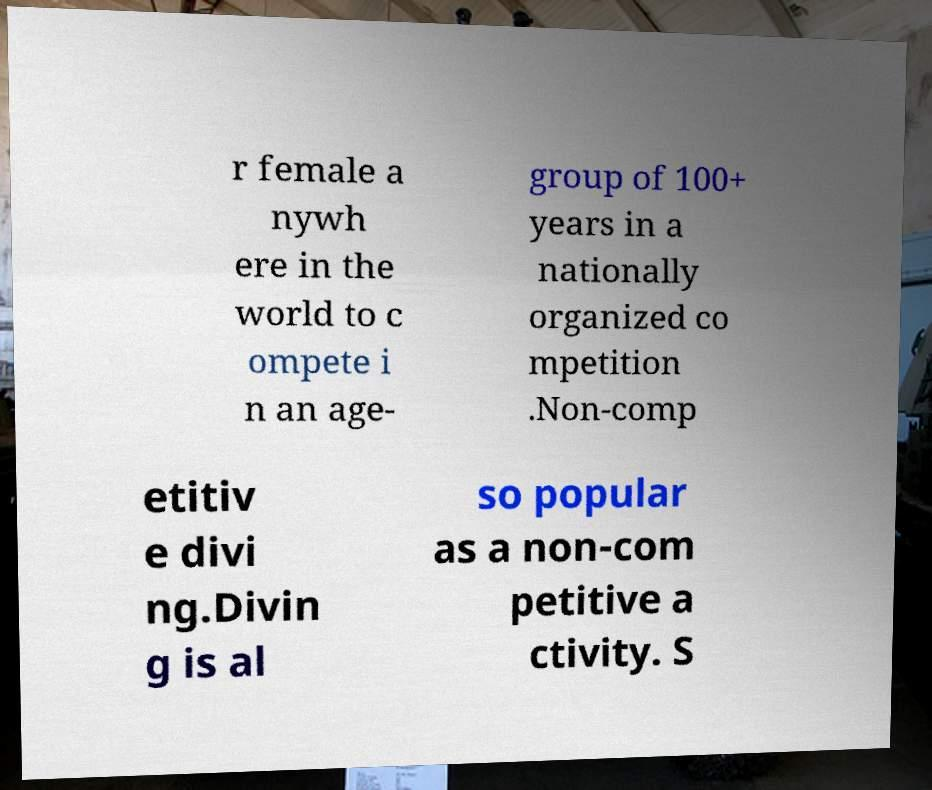Could you extract and type out the text from this image? r female a nywh ere in the world to c ompete i n an age- group of 100+ years in a nationally organized co mpetition .Non-comp etitiv e divi ng.Divin g is al so popular as a non-com petitive a ctivity. S 